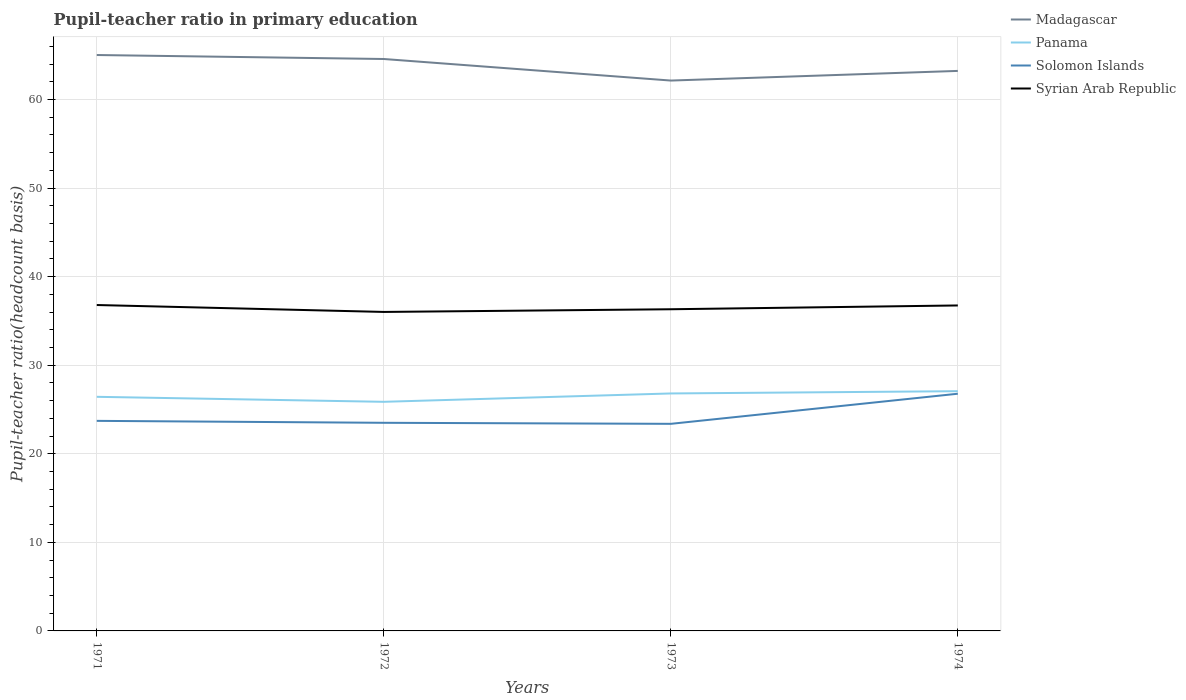Is the number of lines equal to the number of legend labels?
Ensure brevity in your answer.  Yes. Across all years, what is the maximum pupil-teacher ratio in primary education in Solomon Islands?
Your response must be concise. 23.38. In which year was the pupil-teacher ratio in primary education in Syrian Arab Republic maximum?
Offer a very short reply. 1972. What is the total pupil-teacher ratio in primary education in Syrian Arab Republic in the graph?
Ensure brevity in your answer.  0.48. What is the difference between the highest and the second highest pupil-teacher ratio in primary education in Solomon Islands?
Make the answer very short. 3.4. What is the difference between the highest and the lowest pupil-teacher ratio in primary education in Syrian Arab Republic?
Your response must be concise. 2. Are the values on the major ticks of Y-axis written in scientific E-notation?
Your answer should be compact. No. Does the graph contain grids?
Provide a short and direct response. Yes. Where does the legend appear in the graph?
Keep it short and to the point. Top right. How are the legend labels stacked?
Offer a terse response. Vertical. What is the title of the graph?
Give a very brief answer. Pupil-teacher ratio in primary education. What is the label or title of the Y-axis?
Your answer should be very brief. Pupil-teacher ratio(headcount basis). What is the Pupil-teacher ratio(headcount basis) of Madagascar in 1971?
Your response must be concise. 65.03. What is the Pupil-teacher ratio(headcount basis) in Panama in 1971?
Offer a terse response. 26.44. What is the Pupil-teacher ratio(headcount basis) of Solomon Islands in 1971?
Your answer should be compact. 23.72. What is the Pupil-teacher ratio(headcount basis) of Syrian Arab Republic in 1971?
Offer a terse response. 36.8. What is the Pupil-teacher ratio(headcount basis) of Madagascar in 1972?
Make the answer very short. 64.58. What is the Pupil-teacher ratio(headcount basis) in Panama in 1972?
Keep it short and to the point. 25.87. What is the Pupil-teacher ratio(headcount basis) in Solomon Islands in 1972?
Your answer should be very brief. 23.5. What is the Pupil-teacher ratio(headcount basis) in Syrian Arab Republic in 1972?
Make the answer very short. 36.02. What is the Pupil-teacher ratio(headcount basis) of Madagascar in 1973?
Offer a very short reply. 62.15. What is the Pupil-teacher ratio(headcount basis) of Panama in 1973?
Give a very brief answer. 26.81. What is the Pupil-teacher ratio(headcount basis) in Solomon Islands in 1973?
Give a very brief answer. 23.38. What is the Pupil-teacher ratio(headcount basis) of Syrian Arab Republic in 1973?
Offer a very short reply. 36.32. What is the Pupil-teacher ratio(headcount basis) of Madagascar in 1974?
Your answer should be compact. 63.24. What is the Pupil-teacher ratio(headcount basis) in Panama in 1974?
Offer a very short reply. 27.07. What is the Pupil-teacher ratio(headcount basis) of Solomon Islands in 1974?
Your response must be concise. 26.78. What is the Pupil-teacher ratio(headcount basis) in Syrian Arab Republic in 1974?
Ensure brevity in your answer.  36.75. Across all years, what is the maximum Pupil-teacher ratio(headcount basis) of Madagascar?
Ensure brevity in your answer.  65.03. Across all years, what is the maximum Pupil-teacher ratio(headcount basis) of Panama?
Give a very brief answer. 27.07. Across all years, what is the maximum Pupil-teacher ratio(headcount basis) of Solomon Islands?
Make the answer very short. 26.78. Across all years, what is the maximum Pupil-teacher ratio(headcount basis) in Syrian Arab Republic?
Offer a terse response. 36.8. Across all years, what is the minimum Pupil-teacher ratio(headcount basis) in Madagascar?
Your response must be concise. 62.15. Across all years, what is the minimum Pupil-teacher ratio(headcount basis) in Panama?
Your answer should be compact. 25.87. Across all years, what is the minimum Pupil-teacher ratio(headcount basis) in Solomon Islands?
Ensure brevity in your answer.  23.38. Across all years, what is the minimum Pupil-teacher ratio(headcount basis) in Syrian Arab Republic?
Offer a terse response. 36.02. What is the total Pupil-teacher ratio(headcount basis) in Madagascar in the graph?
Offer a terse response. 255. What is the total Pupil-teacher ratio(headcount basis) of Panama in the graph?
Make the answer very short. 106.19. What is the total Pupil-teacher ratio(headcount basis) of Solomon Islands in the graph?
Offer a terse response. 97.39. What is the total Pupil-teacher ratio(headcount basis) of Syrian Arab Republic in the graph?
Provide a short and direct response. 145.9. What is the difference between the Pupil-teacher ratio(headcount basis) in Madagascar in 1971 and that in 1972?
Provide a short and direct response. 0.45. What is the difference between the Pupil-teacher ratio(headcount basis) in Panama in 1971 and that in 1972?
Offer a terse response. 0.56. What is the difference between the Pupil-teacher ratio(headcount basis) of Solomon Islands in 1971 and that in 1972?
Offer a terse response. 0.22. What is the difference between the Pupil-teacher ratio(headcount basis) in Syrian Arab Republic in 1971 and that in 1972?
Your response must be concise. 0.78. What is the difference between the Pupil-teacher ratio(headcount basis) of Madagascar in 1971 and that in 1973?
Make the answer very short. 2.88. What is the difference between the Pupil-teacher ratio(headcount basis) of Panama in 1971 and that in 1973?
Give a very brief answer. -0.38. What is the difference between the Pupil-teacher ratio(headcount basis) of Solomon Islands in 1971 and that in 1973?
Your answer should be compact. 0.34. What is the difference between the Pupil-teacher ratio(headcount basis) of Syrian Arab Republic in 1971 and that in 1973?
Ensure brevity in your answer.  0.48. What is the difference between the Pupil-teacher ratio(headcount basis) of Madagascar in 1971 and that in 1974?
Offer a terse response. 1.79. What is the difference between the Pupil-teacher ratio(headcount basis) of Panama in 1971 and that in 1974?
Your answer should be very brief. -0.64. What is the difference between the Pupil-teacher ratio(headcount basis) of Solomon Islands in 1971 and that in 1974?
Your answer should be very brief. -3.06. What is the difference between the Pupil-teacher ratio(headcount basis) of Syrian Arab Republic in 1971 and that in 1974?
Your response must be concise. 0.05. What is the difference between the Pupil-teacher ratio(headcount basis) of Madagascar in 1972 and that in 1973?
Your answer should be very brief. 2.43. What is the difference between the Pupil-teacher ratio(headcount basis) of Panama in 1972 and that in 1973?
Your response must be concise. -0.94. What is the difference between the Pupil-teacher ratio(headcount basis) of Solomon Islands in 1972 and that in 1973?
Offer a very short reply. 0.12. What is the difference between the Pupil-teacher ratio(headcount basis) of Syrian Arab Republic in 1972 and that in 1973?
Make the answer very short. -0.3. What is the difference between the Pupil-teacher ratio(headcount basis) in Madagascar in 1972 and that in 1974?
Your answer should be compact. 1.34. What is the difference between the Pupil-teacher ratio(headcount basis) in Panama in 1972 and that in 1974?
Make the answer very short. -1.2. What is the difference between the Pupil-teacher ratio(headcount basis) in Solomon Islands in 1972 and that in 1974?
Ensure brevity in your answer.  -3.28. What is the difference between the Pupil-teacher ratio(headcount basis) in Syrian Arab Republic in 1972 and that in 1974?
Your response must be concise. -0.73. What is the difference between the Pupil-teacher ratio(headcount basis) of Madagascar in 1973 and that in 1974?
Keep it short and to the point. -1.09. What is the difference between the Pupil-teacher ratio(headcount basis) in Panama in 1973 and that in 1974?
Ensure brevity in your answer.  -0.26. What is the difference between the Pupil-teacher ratio(headcount basis) of Solomon Islands in 1973 and that in 1974?
Your answer should be compact. -3.4. What is the difference between the Pupil-teacher ratio(headcount basis) of Syrian Arab Republic in 1973 and that in 1974?
Provide a succinct answer. -0.43. What is the difference between the Pupil-teacher ratio(headcount basis) in Madagascar in 1971 and the Pupil-teacher ratio(headcount basis) in Panama in 1972?
Offer a terse response. 39.16. What is the difference between the Pupil-teacher ratio(headcount basis) in Madagascar in 1971 and the Pupil-teacher ratio(headcount basis) in Solomon Islands in 1972?
Ensure brevity in your answer.  41.53. What is the difference between the Pupil-teacher ratio(headcount basis) in Madagascar in 1971 and the Pupil-teacher ratio(headcount basis) in Syrian Arab Republic in 1972?
Keep it short and to the point. 29.01. What is the difference between the Pupil-teacher ratio(headcount basis) in Panama in 1971 and the Pupil-teacher ratio(headcount basis) in Solomon Islands in 1972?
Your answer should be compact. 2.93. What is the difference between the Pupil-teacher ratio(headcount basis) of Panama in 1971 and the Pupil-teacher ratio(headcount basis) of Syrian Arab Republic in 1972?
Offer a very short reply. -9.58. What is the difference between the Pupil-teacher ratio(headcount basis) of Solomon Islands in 1971 and the Pupil-teacher ratio(headcount basis) of Syrian Arab Republic in 1972?
Your answer should be compact. -12.3. What is the difference between the Pupil-teacher ratio(headcount basis) in Madagascar in 1971 and the Pupil-teacher ratio(headcount basis) in Panama in 1973?
Keep it short and to the point. 38.22. What is the difference between the Pupil-teacher ratio(headcount basis) of Madagascar in 1971 and the Pupil-teacher ratio(headcount basis) of Solomon Islands in 1973?
Your answer should be very brief. 41.65. What is the difference between the Pupil-teacher ratio(headcount basis) in Madagascar in 1971 and the Pupil-teacher ratio(headcount basis) in Syrian Arab Republic in 1973?
Ensure brevity in your answer.  28.71. What is the difference between the Pupil-teacher ratio(headcount basis) in Panama in 1971 and the Pupil-teacher ratio(headcount basis) in Solomon Islands in 1973?
Provide a succinct answer. 3.05. What is the difference between the Pupil-teacher ratio(headcount basis) of Panama in 1971 and the Pupil-teacher ratio(headcount basis) of Syrian Arab Republic in 1973?
Make the answer very short. -9.89. What is the difference between the Pupil-teacher ratio(headcount basis) in Solomon Islands in 1971 and the Pupil-teacher ratio(headcount basis) in Syrian Arab Republic in 1973?
Your answer should be very brief. -12.6. What is the difference between the Pupil-teacher ratio(headcount basis) in Madagascar in 1971 and the Pupil-teacher ratio(headcount basis) in Panama in 1974?
Make the answer very short. 37.96. What is the difference between the Pupil-teacher ratio(headcount basis) in Madagascar in 1971 and the Pupil-teacher ratio(headcount basis) in Solomon Islands in 1974?
Your response must be concise. 38.25. What is the difference between the Pupil-teacher ratio(headcount basis) in Madagascar in 1971 and the Pupil-teacher ratio(headcount basis) in Syrian Arab Republic in 1974?
Your answer should be compact. 28.28. What is the difference between the Pupil-teacher ratio(headcount basis) of Panama in 1971 and the Pupil-teacher ratio(headcount basis) of Solomon Islands in 1974?
Offer a very short reply. -0.35. What is the difference between the Pupil-teacher ratio(headcount basis) in Panama in 1971 and the Pupil-teacher ratio(headcount basis) in Syrian Arab Republic in 1974?
Offer a very short reply. -10.32. What is the difference between the Pupil-teacher ratio(headcount basis) in Solomon Islands in 1971 and the Pupil-teacher ratio(headcount basis) in Syrian Arab Republic in 1974?
Your answer should be compact. -13.03. What is the difference between the Pupil-teacher ratio(headcount basis) in Madagascar in 1972 and the Pupil-teacher ratio(headcount basis) in Panama in 1973?
Keep it short and to the point. 37.77. What is the difference between the Pupil-teacher ratio(headcount basis) of Madagascar in 1972 and the Pupil-teacher ratio(headcount basis) of Solomon Islands in 1973?
Your answer should be compact. 41.2. What is the difference between the Pupil-teacher ratio(headcount basis) in Madagascar in 1972 and the Pupil-teacher ratio(headcount basis) in Syrian Arab Republic in 1973?
Provide a succinct answer. 28.26. What is the difference between the Pupil-teacher ratio(headcount basis) in Panama in 1972 and the Pupil-teacher ratio(headcount basis) in Solomon Islands in 1973?
Give a very brief answer. 2.49. What is the difference between the Pupil-teacher ratio(headcount basis) of Panama in 1972 and the Pupil-teacher ratio(headcount basis) of Syrian Arab Republic in 1973?
Your answer should be very brief. -10.45. What is the difference between the Pupil-teacher ratio(headcount basis) of Solomon Islands in 1972 and the Pupil-teacher ratio(headcount basis) of Syrian Arab Republic in 1973?
Provide a succinct answer. -12.82. What is the difference between the Pupil-teacher ratio(headcount basis) of Madagascar in 1972 and the Pupil-teacher ratio(headcount basis) of Panama in 1974?
Give a very brief answer. 37.51. What is the difference between the Pupil-teacher ratio(headcount basis) in Madagascar in 1972 and the Pupil-teacher ratio(headcount basis) in Solomon Islands in 1974?
Provide a succinct answer. 37.8. What is the difference between the Pupil-teacher ratio(headcount basis) in Madagascar in 1972 and the Pupil-teacher ratio(headcount basis) in Syrian Arab Republic in 1974?
Your response must be concise. 27.83. What is the difference between the Pupil-teacher ratio(headcount basis) of Panama in 1972 and the Pupil-teacher ratio(headcount basis) of Solomon Islands in 1974?
Ensure brevity in your answer.  -0.91. What is the difference between the Pupil-teacher ratio(headcount basis) in Panama in 1972 and the Pupil-teacher ratio(headcount basis) in Syrian Arab Republic in 1974?
Ensure brevity in your answer.  -10.88. What is the difference between the Pupil-teacher ratio(headcount basis) in Solomon Islands in 1972 and the Pupil-teacher ratio(headcount basis) in Syrian Arab Republic in 1974?
Ensure brevity in your answer.  -13.25. What is the difference between the Pupil-teacher ratio(headcount basis) of Madagascar in 1973 and the Pupil-teacher ratio(headcount basis) of Panama in 1974?
Offer a very short reply. 35.08. What is the difference between the Pupil-teacher ratio(headcount basis) in Madagascar in 1973 and the Pupil-teacher ratio(headcount basis) in Solomon Islands in 1974?
Provide a succinct answer. 35.36. What is the difference between the Pupil-teacher ratio(headcount basis) of Madagascar in 1973 and the Pupil-teacher ratio(headcount basis) of Syrian Arab Republic in 1974?
Give a very brief answer. 25.4. What is the difference between the Pupil-teacher ratio(headcount basis) in Panama in 1973 and the Pupil-teacher ratio(headcount basis) in Solomon Islands in 1974?
Provide a short and direct response. 0.03. What is the difference between the Pupil-teacher ratio(headcount basis) in Panama in 1973 and the Pupil-teacher ratio(headcount basis) in Syrian Arab Republic in 1974?
Ensure brevity in your answer.  -9.94. What is the difference between the Pupil-teacher ratio(headcount basis) of Solomon Islands in 1973 and the Pupil-teacher ratio(headcount basis) of Syrian Arab Republic in 1974?
Give a very brief answer. -13.37. What is the average Pupil-teacher ratio(headcount basis) in Madagascar per year?
Make the answer very short. 63.75. What is the average Pupil-teacher ratio(headcount basis) of Panama per year?
Make the answer very short. 26.55. What is the average Pupil-teacher ratio(headcount basis) of Solomon Islands per year?
Your answer should be very brief. 24.35. What is the average Pupil-teacher ratio(headcount basis) of Syrian Arab Republic per year?
Offer a terse response. 36.47. In the year 1971, what is the difference between the Pupil-teacher ratio(headcount basis) in Madagascar and Pupil-teacher ratio(headcount basis) in Panama?
Offer a very short reply. 38.6. In the year 1971, what is the difference between the Pupil-teacher ratio(headcount basis) of Madagascar and Pupil-teacher ratio(headcount basis) of Solomon Islands?
Your response must be concise. 41.31. In the year 1971, what is the difference between the Pupil-teacher ratio(headcount basis) of Madagascar and Pupil-teacher ratio(headcount basis) of Syrian Arab Republic?
Provide a succinct answer. 28.23. In the year 1971, what is the difference between the Pupil-teacher ratio(headcount basis) in Panama and Pupil-teacher ratio(headcount basis) in Solomon Islands?
Provide a succinct answer. 2.71. In the year 1971, what is the difference between the Pupil-teacher ratio(headcount basis) in Panama and Pupil-teacher ratio(headcount basis) in Syrian Arab Republic?
Ensure brevity in your answer.  -10.37. In the year 1971, what is the difference between the Pupil-teacher ratio(headcount basis) in Solomon Islands and Pupil-teacher ratio(headcount basis) in Syrian Arab Republic?
Provide a short and direct response. -13.08. In the year 1972, what is the difference between the Pupil-teacher ratio(headcount basis) of Madagascar and Pupil-teacher ratio(headcount basis) of Panama?
Your answer should be very brief. 38.71. In the year 1972, what is the difference between the Pupil-teacher ratio(headcount basis) of Madagascar and Pupil-teacher ratio(headcount basis) of Solomon Islands?
Keep it short and to the point. 41.08. In the year 1972, what is the difference between the Pupil-teacher ratio(headcount basis) in Madagascar and Pupil-teacher ratio(headcount basis) in Syrian Arab Republic?
Your answer should be compact. 28.56. In the year 1972, what is the difference between the Pupil-teacher ratio(headcount basis) of Panama and Pupil-teacher ratio(headcount basis) of Solomon Islands?
Make the answer very short. 2.37. In the year 1972, what is the difference between the Pupil-teacher ratio(headcount basis) in Panama and Pupil-teacher ratio(headcount basis) in Syrian Arab Republic?
Provide a short and direct response. -10.15. In the year 1972, what is the difference between the Pupil-teacher ratio(headcount basis) of Solomon Islands and Pupil-teacher ratio(headcount basis) of Syrian Arab Republic?
Provide a short and direct response. -12.52. In the year 1973, what is the difference between the Pupil-teacher ratio(headcount basis) of Madagascar and Pupil-teacher ratio(headcount basis) of Panama?
Offer a terse response. 35.33. In the year 1973, what is the difference between the Pupil-teacher ratio(headcount basis) of Madagascar and Pupil-teacher ratio(headcount basis) of Solomon Islands?
Keep it short and to the point. 38.76. In the year 1973, what is the difference between the Pupil-teacher ratio(headcount basis) in Madagascar and Pupil-teacher ratio(headcount basis) in Syrian Arab Republic?
Offer a very short reply. 25.82. In the year 1973, what is the difference between the Pupil-teacher ratio(headcount basis) of Panama and Pupil-teacher ratio(headcount basis) of Solomon Islands?
Make the answer very short. 3.43. In the year 1973, what is the difference between the Pupil-teacher ratio(headcount basis) of Panama and Pupil-teacher ratio(headcount basis) of Syrian Arab Republic?
Offer a terse response. -9.51. In the year 1973, what is the difference between the Pupil-teacher ratio(headcount basis) of Solomon Islands and Pupil-teacher ratio(headcount basis) of Syrian Arab Republic?
Make the answer very short. -12.94. In the year 1974, what is the difference between the Pupil-teacher ratio(headcount basis) in Madagascar and Pupil-teacher ratio(headcount basis) in Panama?
Your response must be concise. 36.17. In the year 1974, what is the difference between the Pupil-teacher ratio(headcount basis) in Madagascar and Pupil-teacher ratio(headcount basis) in Solomon Islands?
Give a very brief answer. 36.45. In the year 1974, what is the difference between the Pupil-teacher ratio(headcount basis) in Madagascar and Pupil-teacher ratio(headcount basis) in Syrian Arab Republic?
Provide a succinct answer. 26.48. In the year 1974, what is the difference between the Pupil-teacher ratio(headcount basis) of Panama and Pupil-teacher ratio(headcount basis) of Solomon Islands?
Provide a short and direct response. 0.29. In the year 1974, what is the difference between the Pupil-teacher ratio(headcount basis) in Panama and Pupil-teacher ratio(headcount basis) in Syrian Arab Republic?
Your answer should be very brief. -9.68. In the year 1974, what is the difference between the Pupil-teacher ratio(headcount basis) in Solomon Islands and Pupil-teacher ratio(headcount basis) in Syrian Arab Republic?
Provide a short and direct response. -9.97. What is the ratio of the Pupil-teacher ratio(headcount basis) in Madagascar in 1971 to that in 1972?
Provide a short and direct response. 1.01. What is the ratio of the Pupil-teacher ratio(headcount basis) of Panama in 1971 to that in 1972?
Your response must be concise. 1.02. What is the ratio of the Pupil-teacher ratio(headcount basis) of Solomon Islands in 1971 to that in 1972?
Make the answer very short. 1.01. What is the ratio of the Pupil-teacher ratio(headcount basis) of Syrian Arab Republic in 1971 to that in 1972?
Offer a very short reply. 1.02. What is the ratio of the Pupil-teacher ratio(headcount basis) in Madagascar in 1971 to that in 1973?
Your response must be concise. 1.05. What is the ratio of the Pupil-teacher ratio(headcount basis) of Panama in 1971 to that in 1973?
Offer a terse response. 0.99. What is the ratio of the Pupil-teacher ratio(headcount basis) in Solomon Islands in 1971 to that in 1973?
Ensure brevity in your answer.  1.01. What is the ratio of the Pupil-teacher ratio(headcount basis) of Syrian Arab Republic in 1971 to that in 1973?
Your answer should be compact. 1.01. What is the ratio of the Pupil-teacher ratio(headcount basis) of Madagascar in 1971 to that in 1974?
Your answer should be compact. 1.03. What is the ratio of the Pupil-teacher ratio(headcount basis) in Panama in 1971 to that in 1974?
Offer a terse response. 0.98. What is the ratio of the Pupil-teacher ratio(headcount basis) in Solomon Islands in 1971 to that in 1974?
Your response must be concise. 0.89. What is the ratio of the Pupil-teacher ratio(headcount basis) of Madagascar in 1972 to that in 1973?
Make the answer very short. 1.04. What is the ratio of the Pupil-teacher ratio(headcount basis) in Panama in 1972 to that in 1973?
Ensure brevity in your answer.  0.96. What is the ratio of the Pupil-teacher ratio(headcount basis) in Solomon Islands in 1972 to that in 1973?
Give a very brief answer. 1. What is the ratio of the Pupil-teacher ratio(headcount basis) in Syrian Arab Republic in 1972 to that in 1973?
Provide a short and direct response. 0.99. What is the ratio of the Pupil-teacher ratio(headcount basis) in Madagascar in 1972 to that in 1974?
Give a very brief answer. 1.02. What is the ratio of the Pupil-teacher ratio(headcount basis) of Panama in 1972 to that in 1974?
Your answer should be compact. 0.96. What is the ratio of the Pupil-teacher ratio(headcount basis) of Solomon Islands in 1972 to that in 1974?
Make the answer very short. 0.88. What is the ratio of the Pupil-teacher ratio(headcount basis) of Syrian Arab Republic in 1972 to that in 1974?
Make the answer very short. 0.98. What is the ratio of the Pupil-teacher ratio(headcount basis) in Madagascar in 1973 to that in 1974?
Your answer should be compact. 0.98. What is the ratio of the Pupil-teacher ratio(headcount basis) in Panama in 1973 to that in 1974?
Your response must be concise. 0.99. What is the ratio of the Pupil-teacher ratio(headcount basis) in Solomon Islands in 1973 to that in 1974?
Your response must be concise. 0.87. What is the ratio of the Pupil-teacher ratio(headcount basis) in Syrian Arab Republic in 1973 to that in 1974?
Provide a short and direct response. 0.99. What is the difference between the highest and the second highest Pupil-teacher ratio(headcount basis) of Madagascar?
Your answer should be compact. 0.45. What is the difference between the highest and the second highest Pupil-teacher ratio(headcount basis) of Panama?
Offer a very short reply. 0.26. What is the difference between the highest and the second highest Pupil-teacher ratio(headcount basis) in Solomon Islands?
Give a very brief answer. 3.06. What is the difference between the highest and the second highest Pupil-teacher ratio(headcount basis) in Syrian Arab Republic?
Offer a very short reply. 0.05. What is the difference between the highest and the lowest Pupil-teacher ratio(headcount basis) of Madagascar?
Provide a succinct answer. 2.88. What is the difference between the highest and the lowest Pupil-teacher ratio(headcount basis) in Panama?
Your answer should be compact. 1.2. What is the difference between the highest and the lowest Pupil-teacher ratio(headcount basis) in Solomon Islands?
Provide a succinct answer. 3.4. What is the difference between the highest and the lowest Pupil-teacher ratio(headcount basis) in Syrian Arab Republic?
Your answer should be compact. 0.78. 